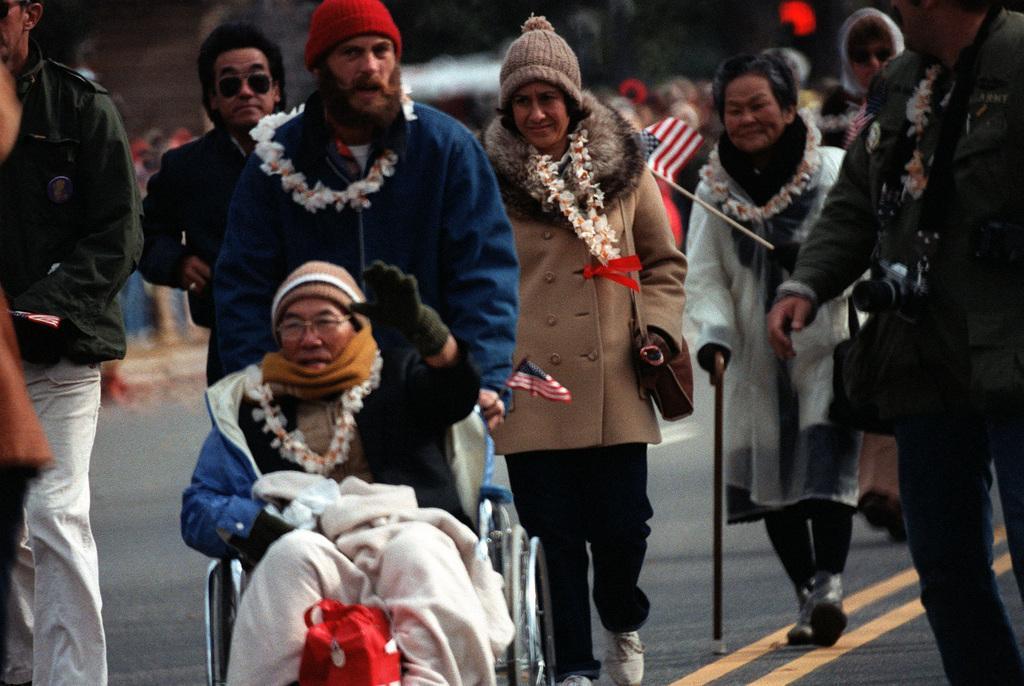In one or two sentences, can you explain what this image depicts? In this image a person sitting on wheel chair, behind them there are few people, one woman holding stick visible on road, in the background may be there are group of people visible. 